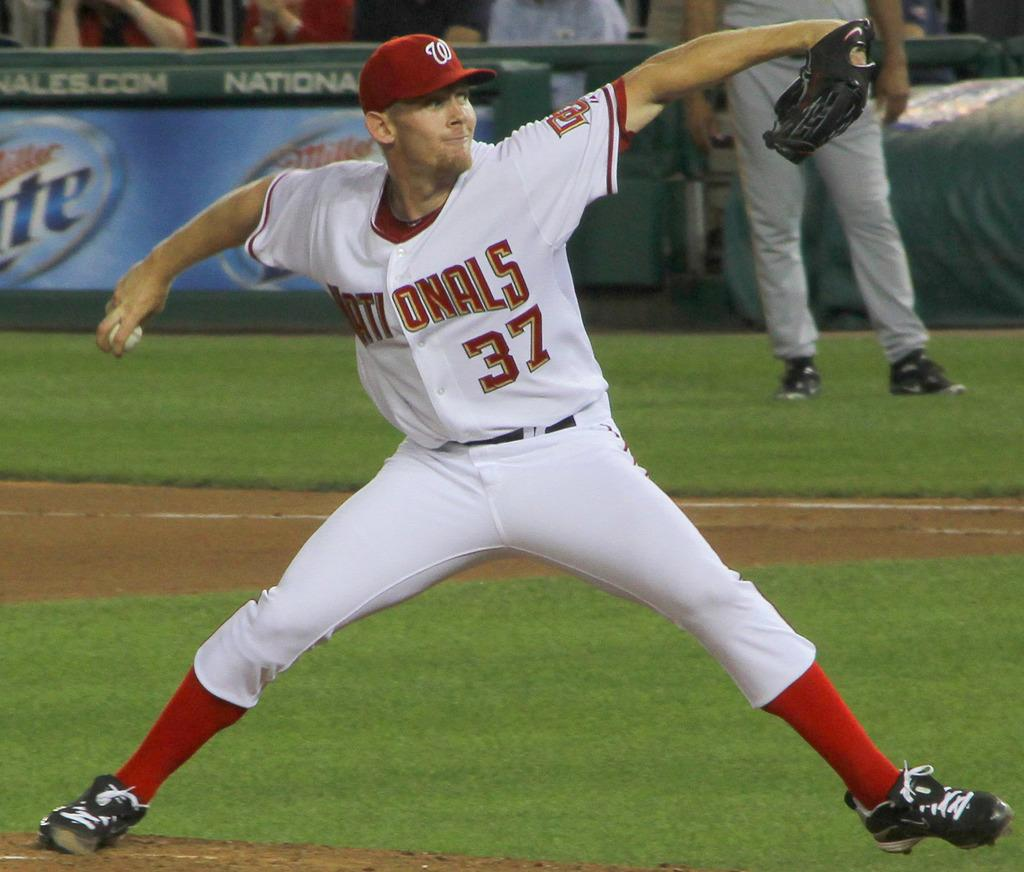<image>
Relay a brief, clear account of the picture shown. a player with the number 37 on their jersey 